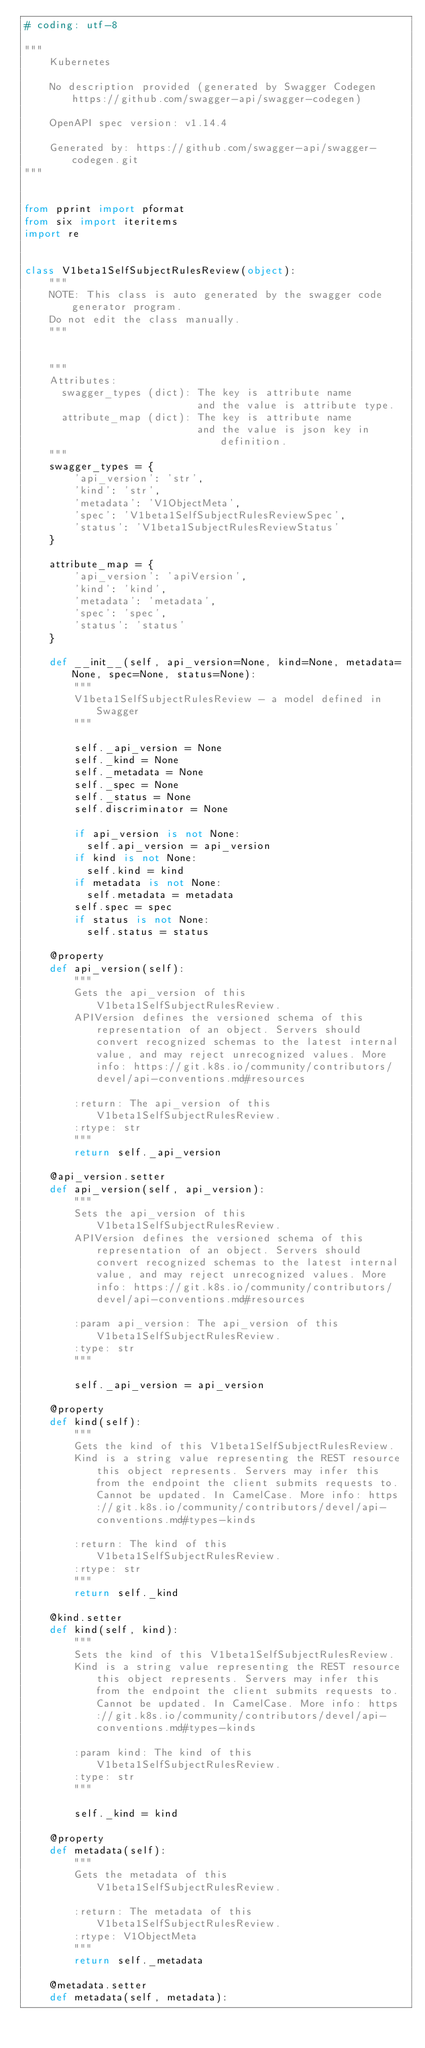<code> <loc_0><loc_0><loc_500><loc_500><_Python_># coding: utf-8

"""
    Kubernetes

    No description provided (generated by Swagger Codegen https://github.com/swagger-api/swagger-codegen)

    OpenAPI spec version: v1.14.4
    
    Generated by: https://github.com/swagger-api/swagger-codegen.git
"""


from pprint import pformat
from six import iteritems
import re


class V1beta1SelfSubjectRulesReview(object):
    """
    NOTE: This class is auto generated by the swagger code generator program.
    Do not edit the class manually.
    """


    """
    Attributes:
      swagger_types (dict): The key is attribute name
                            and the value is attribute type.
      attribute_map (dict): The key is attribute name
                            and the value is json key in definition.
    """
    swagger_types = {
        'api_version': 'str',
        'kind': 'str',
        'metadata': 'V1ObjectMeta',
        'spec': 'V1beta1SelfSubjectRulesReviewSpec',
        'status': 'V1beta1SubjectRulesReviewStatus'
    }

    attribute_map = {
        'api_version': 'apiVersion',
        'kind': 'kind',
        'metadata': 'metadata',
        'spec': 'spec',
        'status': 'status'
    }

    def __init__(self, api_version=None, kind=None, metadata=None, spec=None, status=None):
        """
        V1beta1SelfSubjectRulesReview - a model defined in Swagger
        """

        self._api_version = None
        self._kind = None
        self._metadata = None
        self._spec = None
        self._status = None
        self.discriminator = None

        if api_version is not None:
          self.api_version = api_version
        if kind is not None:
          self.kind = kind
        if metadata is not None:
          self.metadata = metadata
        self.spec = spec
        if status is not None:
          self.status = status

    @property
    def api_version(self):
        """
        Gets the api_version of this V1beta1SelfSubjectRulesReview.
        APIVersion defines the versioned schema of this representation of an object. Servers should convert recognized schemas to the latest internal value, and may reject unrecognized values. More info: https://git.k8s.io/community/contributors/devel/api-conventions.md#resources

        :return: The api_version of this V1beta1SelfSubjectRulesReview.
        :rtype: str
        """
        return self._api_version

    @api_version.setter
    def api_version(self, api_version):
        """
        Sets the api_version of this V1beta1SelfSubjectRulesReview.
        APIVersion defines the versioned schema of this representation of an object. Servers should convert recognized schemas to the latest internal value, and may reject unrecognized values. More info: https://git.k8s.io/community/contributors/devel/api-conventions.md#resources

        :param api_version: The api_version of this V1beta1SelfSubjectRulesReview.
        :type: str
        """

        self._api_version = api_version

    @property
    def kind(self):
        """
        Gets the kind of this V1beta1SelfSubjectRulesReview.
        Kind is a string value representing the REST resource this object represents. Servers may infer this from the endpoint the client submits requests to. Cannot be updated. In CamelCase. More info: https://git.k8s.io/community/contributors/devel/api-conventions.md#types-kinds

        :return: The kind of this V1beta1SelfSubjectRulesReview.
        :rtype: str
        """
        return self._kind

    @kind.setter
    def kind(self, kind):
        """
        Sets the kind of this V1beta1SelfSubjectRulesReview.
        Kind is a string value representing the REST resource this object represents. Servers may infer this from the endpoint the client submits requests to. Cannot be updated. In CamelCase. More info: https://git.k8s.io/community/contributors/devel/api-conventions.md#types-kinds

        :param kind: The kind of this V1beta1SelfSubjectRulesReview.
        :type: str
        """

        self._kind = kind

    @property
    def metadata(self):
        """
        Gets the metadata of this V1beta1SelfSubjectRulesReview.

        :return: The metadata of this V1beta1SelfSubjectRulesReview.
        :rtype: V1ObjectMeta
        """
        return self._metadata

    @metadata.setter
    def metadata(self, metadata):</code> 